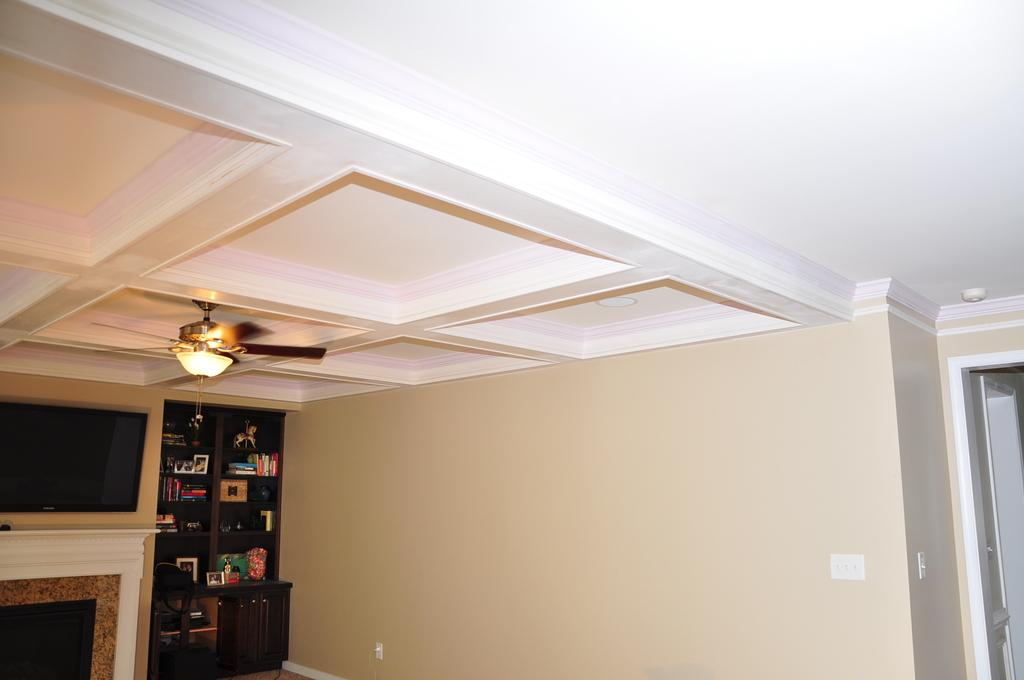What part of a house is visible in the image? The image shows an upper portion of a house. What electronic device can be seen in the house? There is a television in the house. What type of storage is present in the house? There is a cupboard filled with books in the house. How is the house ventilated or cooled? A fan is fitted to the roof of the house. Where is the goat kept in the house? There is no goat present in the image or mentioned in the facts provided. 